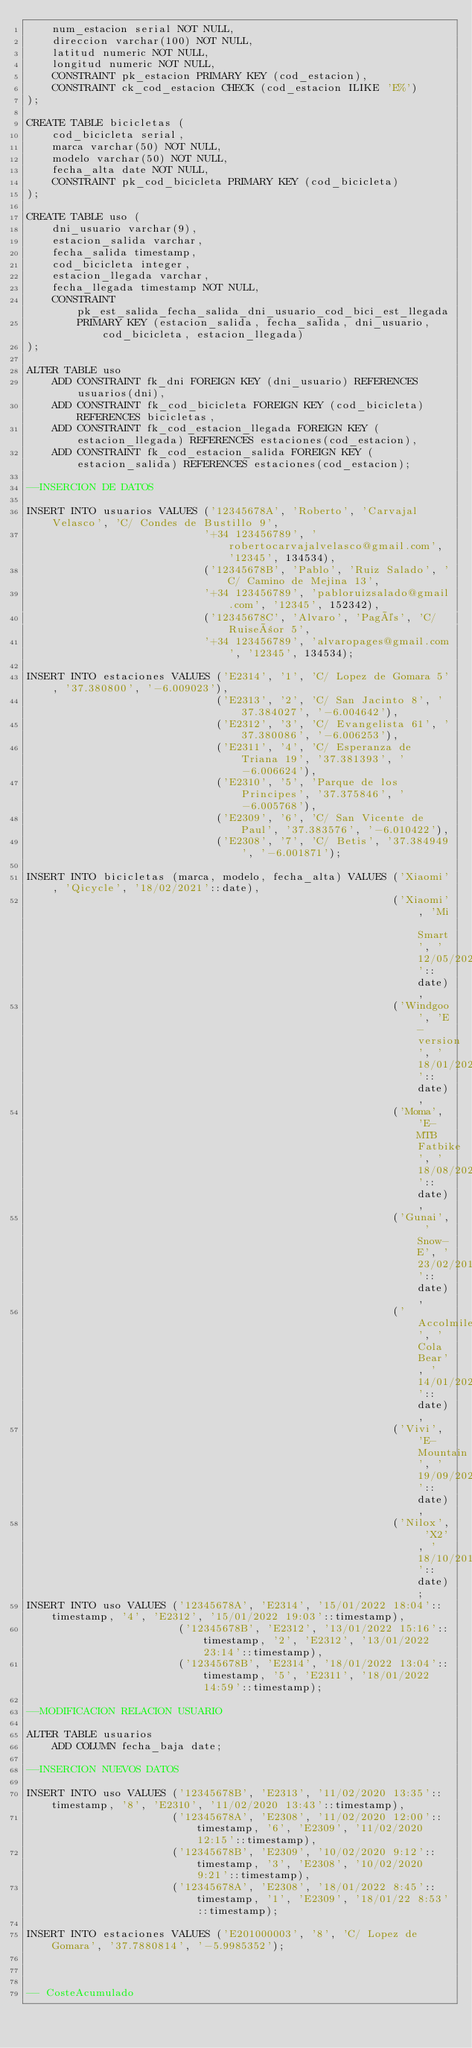<code> <loc_0><loc_0><loc_500><loc_500><_SQL_>	num_estacion serial NOT NULL,
	direccion varchar(100) NOT NULL,
	latitud numeric NOT NULL,
	longitud numeric NOT NULL,
	CONSTRAINT pk_estacion PRIMARY KEY (cod_estacion),
	CONSTRAINT ck_cod_estacion CHECK (cod_estacion ILIKE 'E%')
);

CREATE TABLE bicicletas (
	cod_bicicleta serial,
	marca varchar(50) NOT NULL,
	modelo varchar(50) NOT NULL,
	fecha_alta date NOT NULL,
	CONSTRAINT pk_cod_bicicleta PRIMARY KEY (cod_bicicleta)
);

CREATE TABLE uso (
	dni_usuario varchar(9),
	estacion_salida varchar,
	fecha_salida timestamp,	
	cod_bicicleta integer,
	estacion_llegada varchar,
	fecha_llegada timestamp NOT NULL,
	CONSTRAINT pk_est_salida_fecha_salida_dni_usuario_cod_bici_est_llegada
		PRIMARY KEY (estacion_salida, fecha_salida, dni_usuario, cod_bicicleta, estacion_llegada)
);

ALTER TABLE uso
	ADD CONSTRAINT fk_dni FOREIGN KEY (dni_usuario) REFERENCES usuarios(dni),
	ADD CONSTRAINT fk_cod_bicicleta FOREIGN KEY (cod_bicicleta) REFERENCES bicicletas,
	ADD CONSTRAINT fk_cod_estacion_llegada FOREIGN KEY (estacion_llegada) REFERENCES estaciones(cod_estacion),
	ADD CONSTRAINT fk_cod_estacion_salida FOREIGN KEY (estacion_salida) REFERENCES estaciones(cod_estacion);

--INSERCION DE DATOS

INSERT INTO usuarios VALUES ('12345678A', 'Roberto', 'Carvajal Velasco', 'C/ Condes de Bustillo 9',
							'+34 123456789', 'robertocarvajalvelasco@gmail.com', '12345', 134534),
							('12345678B', 'Pablo', 'Ruiz Salado', 'C/ Camino de Mejina 13',
							'+34 123456789', 'pabloruizsalado@gmail.com', '12345', 152342),
							('12345678C', 'Alvaro', 'Pagés', 'C/ Ruiseñor 5',
							'+34 123456789', 'alvaropages@gmail.com', '12345', 134534);

INSERT INTO estaciones VALUES ('E2314', '1', 'C/ Lopez de Gomara 5', '37.380800', '-6.009023'),
							  ('E2313', '2', 'C/ San Jacinto 8', '37.384027', '-6.004642'),
							  ('E2312', '3', 'C/ Evangelista 61', '37.380086', '-6.006253'),
							  ('E2311', '4', 'C/ Esperanza de Triana 19', '37.381393', '-6.006624'),
							  ('E2310', '5', 'Parque de los Principes', '37.375846', '-6.005768'),
							  ('E2309', '6', 'C/ San Vicente de Paul', '37.383576', '-6.010422'),
							  ('E2308', '7', 'C/ Betis', '37.384949', '-6.001871');
							  
INSERT INTO bicicletas (marca, modelo, fecha_alta) VALUES ('Xiaomi', 'Qicycle', '18/02/2021'::date),
														  ('Xiaomi', 'Mi Smart', '12/05/2021'::date),
														  ('Windgoo', 'E-version', '18/01/2022'::date),
														  ('Moma', 'E-MTB Fatbike', '18/08/2020'::date),
														  ('Gunai', 'Snow-E', '23/02/2019'::date),
														  ('Accolmile', 'Cola Bear', '14/01/2022'::date),
														  ('Vivi', 'E-Mountain', '19/09/2021'::date),
														  ('Nilox', 'X2', '18/10/2018'::date);
INSERT INTO uso VALUES ('12345678A', 'E2314', '15/01/2022 18:04'::timestamp, '4', 'E2312', '15/01/2022 19:03'::timestamp),
						('12345678B', 'E2312', '13/01/2022 15:16'::timestamp, '2', 'E2312', '13/01/2022 23:14'::timestamp),
						('12345678B', 'E2314', '18/01/2022 13:04'::timestamp, '5', 'E2311', '18/01/2022 14:59'::timestamp);

--MODIFICACION RELACION USUARIO

ALTER TABLE usuarios 
	ADD COLUMN fecha_baja date;

--INSERCION NUEVOS DATOS

INSERT INTO uso VALUES ('12345678B', 'E2313', '11/02/2020 13:35'::timestamp, '8', 'E2310', '11/02/2020 13:43'::timestamp),
					   ('12345678A', 'E2308', '11/02/2020 12:00'::timestamp, '6', 'E2309', '11/02/2020 12:15'::timestamp),
					   ('12345678B', 'E2309', '10/02/2020 9:12'::timestamp, '3', 'E2308', '10/02/2020 9:21'::timestamp),
					   ('12345678A', 'E2308', '18/01/2022 8:45'::timestamp, '1', 'E2309', '18/01/22 8:53'::timestamp);

INSERT INTO estaciones VALUES ('E201000003', '8', 'C/ Lopez de Gomara', '37.7880814', '-5.9985352');
					   


-- CosteAcumulado
	</code> 